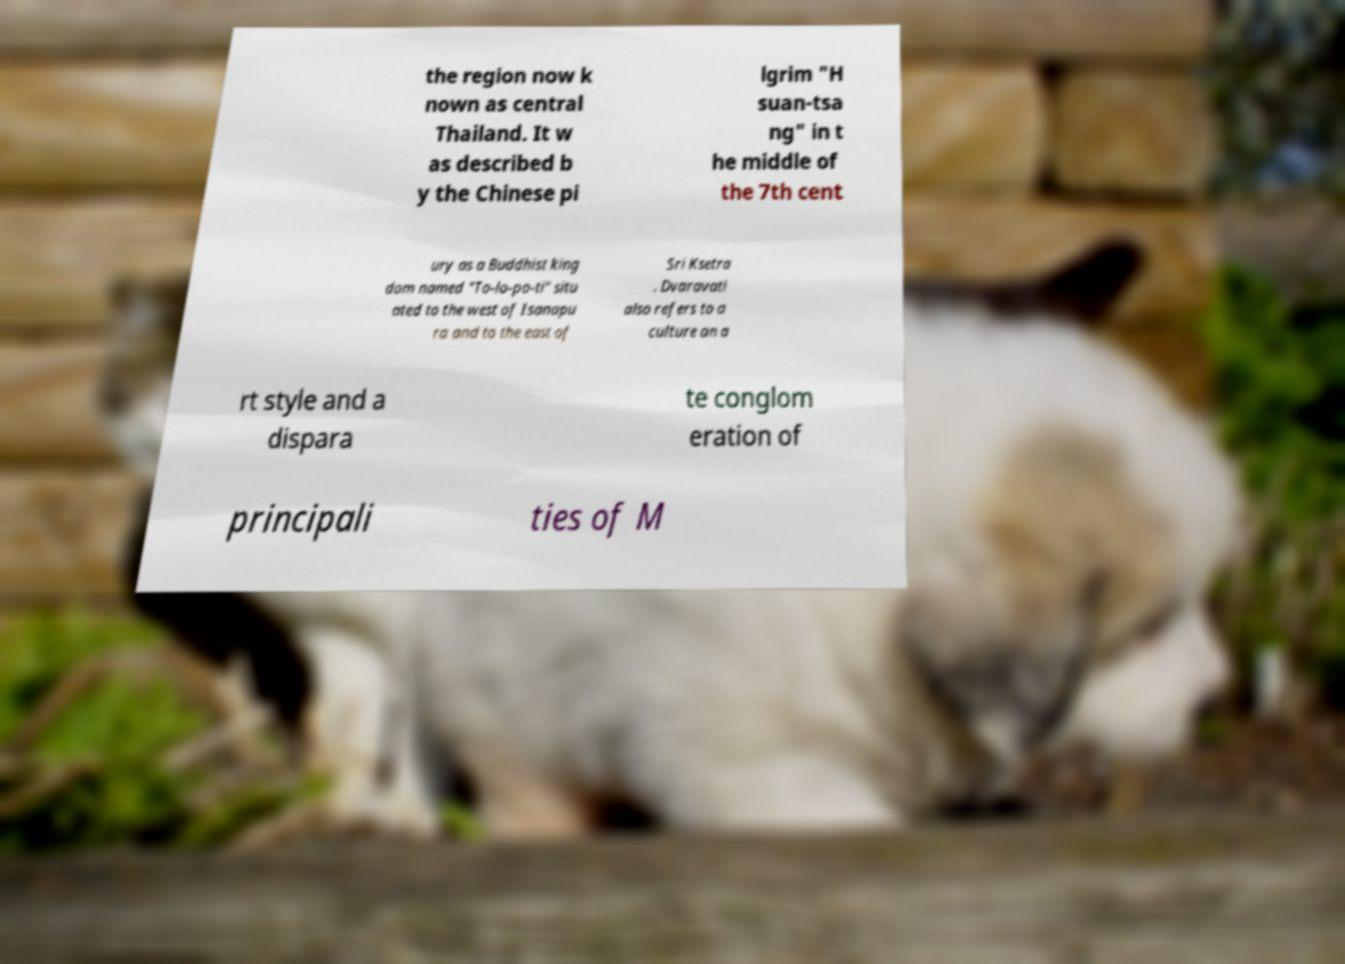Please read and relay the text visible in this image. What does it say? the region now k nown as central Thailand. It w as described b y the Chinese pi lgrim "H suan-tsa ng" in t he middle of the 7th cent ury as a Buddhist king dom named "To-lo-po-ti" situ ated to the west of Isanapu ra and to the east of Sri Ksetra . Dvaravati also refers to a culture an a rt style and a dispara te conglom eration of principali ties of M 